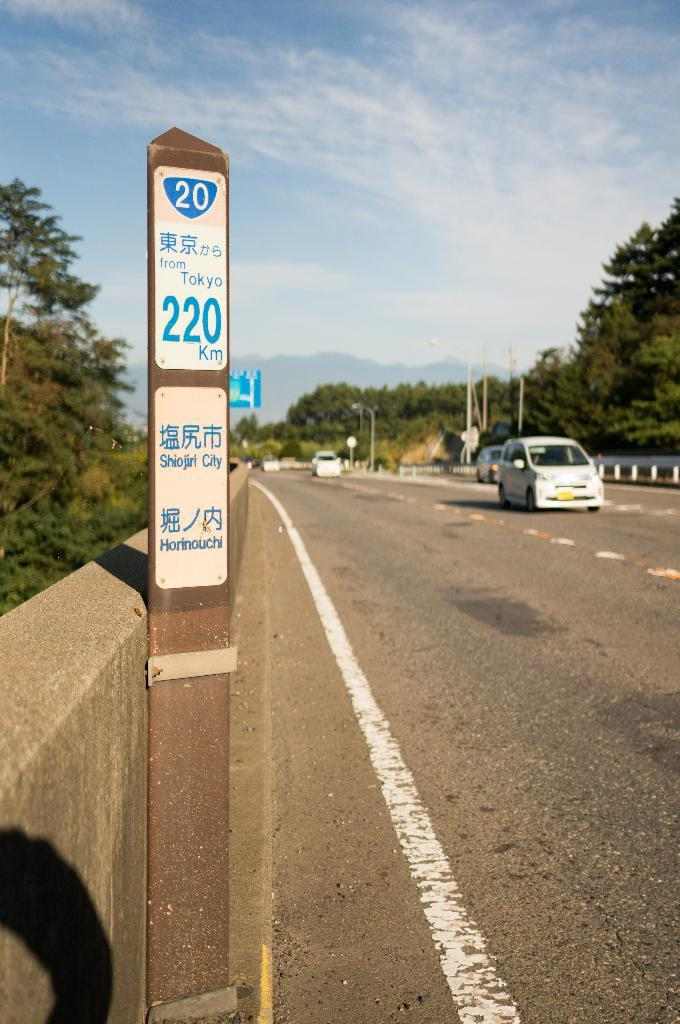<image>
Give a short and clear explanation of the subsequent image. A street post shows a sign that says 200 km 